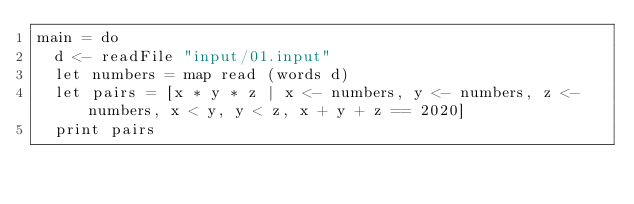<code> <loc_0><loc_0><loc_500><loc_500><_Haskell_>main = do
  d <- readFile "input/01.input"
  let numbers = map read (words d)
  let pairs = [x * y * z | x <- numbers, y <- numbers, z <- numbers, x < y, y < z, x + y + z == 2020]
  print pairs
</code> 